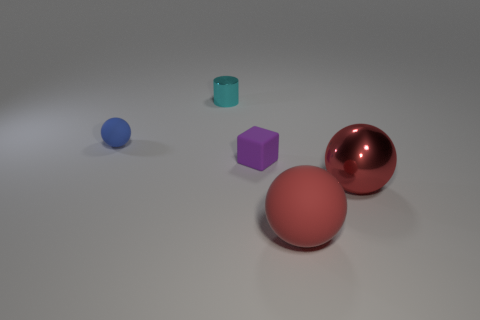What number of cylinders are small cyan rubber things or tiny things?
Provide a succinct answer. 1. How many matte balls are in front of the large red metallic thing and behind the small purple matte thing?
Offer a very short reply. 0. What number of other things are the same color as the shiny cylinder?
Keep it short and to the point. 0. The tiny matte thing right of the small cyan cylinder has what shape?
Ensure brevity in your answer.  Cube. Is the material of the tiny cyan cylinder the same as the small blue sphere?
Make the answer very short. No. Are there any other things that are the same size as the purple thing?
Your answer should be very brief. Yes. There is a large metallic object; how many tiny purple matte cubes are in front of it?
Offer a very short reply. 0. There is a small matte object to the left of the tiny matte object that is to the right of the tiny blue sphere; what shape is it?
Your answer should be very brief. Sphere. Is there any other thing that is the same shape as the blue rubber thing?
Offer a very short reply. Yes. Are there more small blue matte spheres that are in front of the tiny blue rubber ball than yellow shiny balls?
Your answer should be compact. No. 